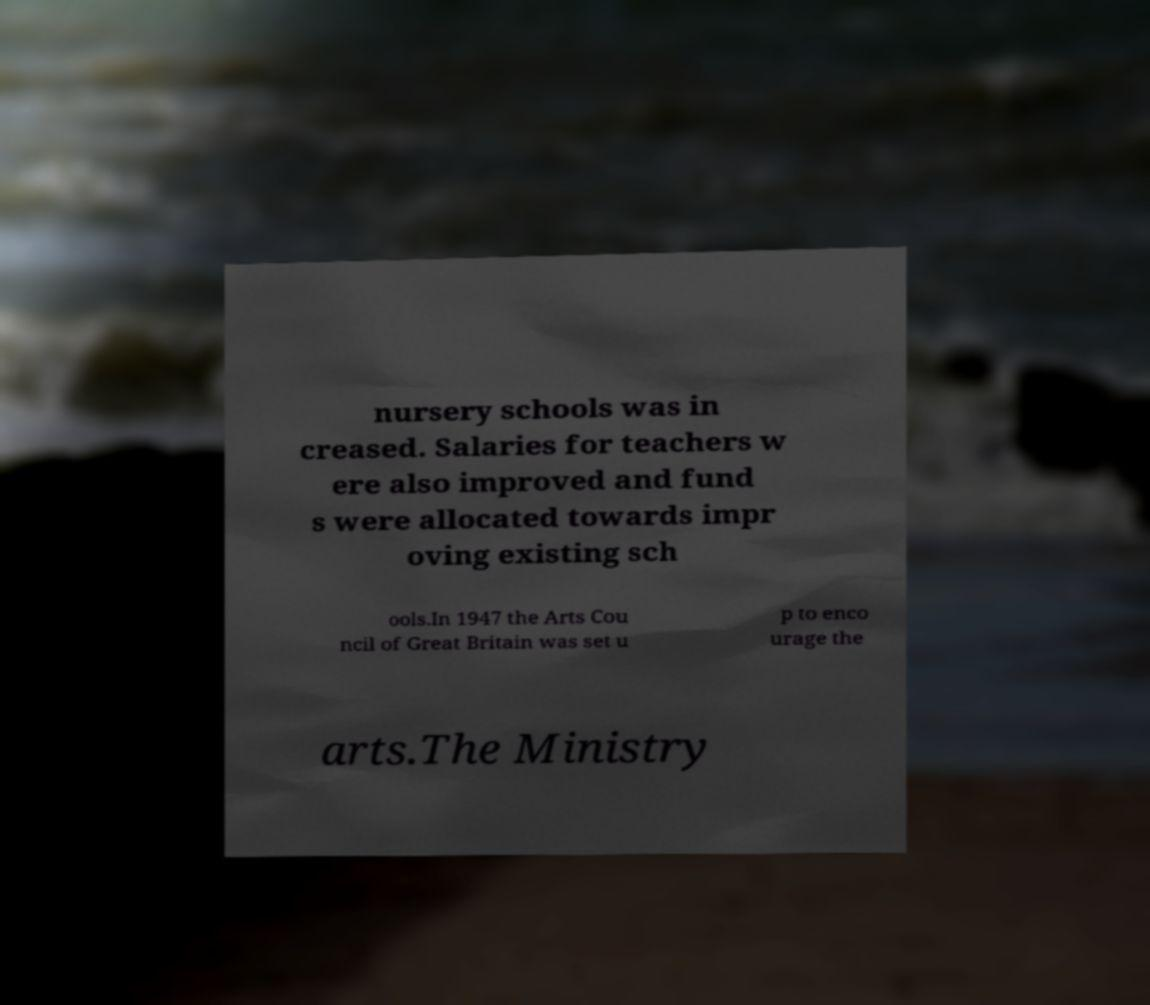I need the written content from this picture converted into text. Can you do that? nursery schools was in creased. Salaries for teachers w ere also improved and fund s were allocated towards impr oving existing sch ools.In 1947 the Arts Cou ncil of Great Britain was set u p to enco urage the arts.The Ministry 